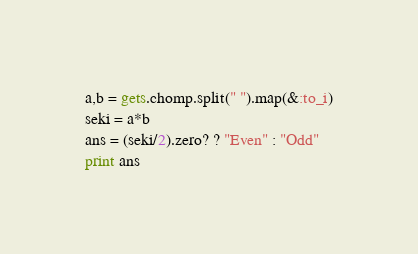Convert code to text. <code><loc_0><loc_0><loc_500><loc_500><_Ruby_>a,b = gets.chomp.split(" ").map(&:to_i)
seki = a*b
ans = (seki/2).zero? ? "Even" : "Odd"
print ans</code> 